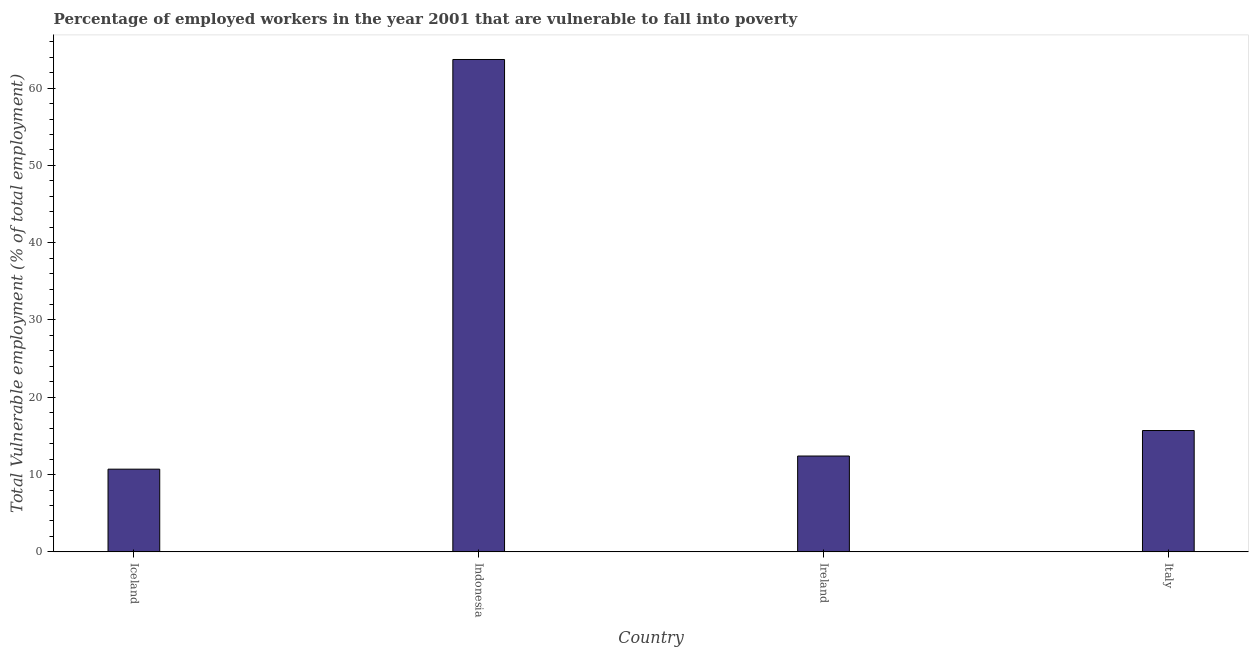Does the graph contain any zero values?
Make the answer very short. No. What is the title of the graph?
Provide a succinct answer. Percentage of employed workers in the year 2001 that are vulnerable to fall into poverty. What is the label or title of the X-axis?
Your response must be concise. Country. What is the label or title of the Y-axis?
Give a very brief answer. Total Vulnerable employment (% of total employment). What is the total vulnerable employment in Italy?
Your answer should be compact. 15.7. Across all countries, what is the maximum total vulnerable employment?
Make the answer very short. 63.7. Across all countries, what is the minimum total vulnerable employment?
Ensure brevity in your answer.  10.7. In which country was the total vulnerable employment maximum?
Your answer should be compact. Indonesia. What is the sum of the total vulnerable employment?
Offer a very short reply. 102.5. What is the difference between the total vulnerable employment in Indonesia and Ireland?
Your answer should be very brief. 51.3. What is the average total vulnerable employment per country?
Give a very brief answer. 25.62. What is the median total vulnerable employment?
Your response must be concise. 14.05. What is the ratio of the total vulnerable employment in Iceland to that in Italy?
Your answer should be very brief. 0.68. Is the total vulnerable employment in Ireland less than that in Italy?
Ensure brevity in your answer.  Yes. What is the difference between the highest and the lowest total vulnerable employment?
Offer a terse response. 53. In how many countries, is the total vulnerable employment greater than the average total vulnerable employment taken over all countries?
Make the answer very short. 1. What is the difference between two consecutive major ticks on the Y-axis?
Provide a short and direct response. 10. What is the Total Vulnerable employment (% of total employment) of Iceland?
Keep it short and to the point. 10.7. What is the Total Vulnerable employment (% of total employment) in Indonesia?
Provide a short and direct response. 63.7. What is the Total Vulnerable employment (% of total employment) in Ireland?
Provide a short and direct response. 12.4. What is the Total Vulnerable employment (% of total employment) of Italy?
Provide a succinct answer. 15.7. What is the difference between the Total Vulnerable employment (% of total employment) in Iceland and Indonesia?
Ensure brevity in your answer.  -53. What is the difference between the Total Vulnerable employment (% of total employment) in Iceland and Ireland?
Provide a short and direct response. -1.7. What is the difference between the Total Vulnerable employment (% of total employment) in Indonesia and Ireland?
Offer a terse response. 51.3. What is the ratio of the Total Vulnerable employment (% of total employment) in Iceland to that in Indonesia?
Your response must be concise. 0.17. What is the ratio of the Total Vulnerable employment (% of total employment) in Iceland to that in Ireland?
Offer a terse response. 0.86. What is the ratio of the Total Vulnerable employment (% of total employment) in Iceland to that in Italy?
Provide a short and direct response. 0.68. What is the ratio of the Total Vulnerable employment (% of total employment) in Indonesia to that in Ireland?
Ensure brevity in your answer.  5.14. What is the ratio of the Total Vulnerable employment (% of total employment) in Indonesia to that in Italy?
Your answer should be very brief. 4.06. What is the ratio of the Total Vulnerable employment (% of total employment) in Ireland to that in Italy?
Ensure brevity in your answer.  0.79. 